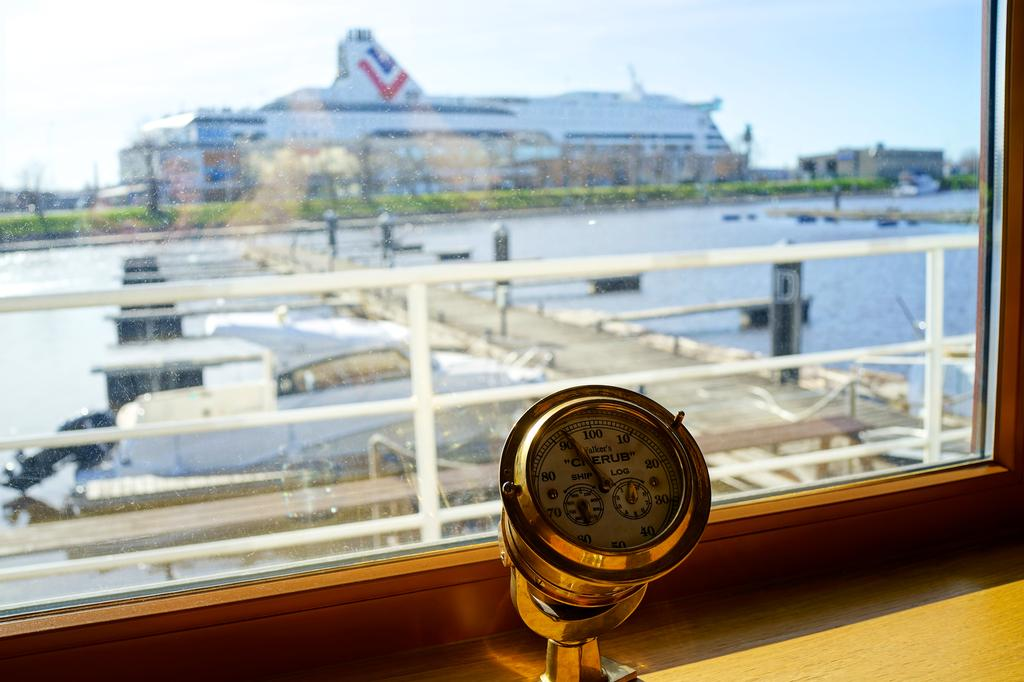Provide a one-sentence caption for the provided image. A dial reads "Walker's Cherub" and has numbers from 10 to 100 on it. 